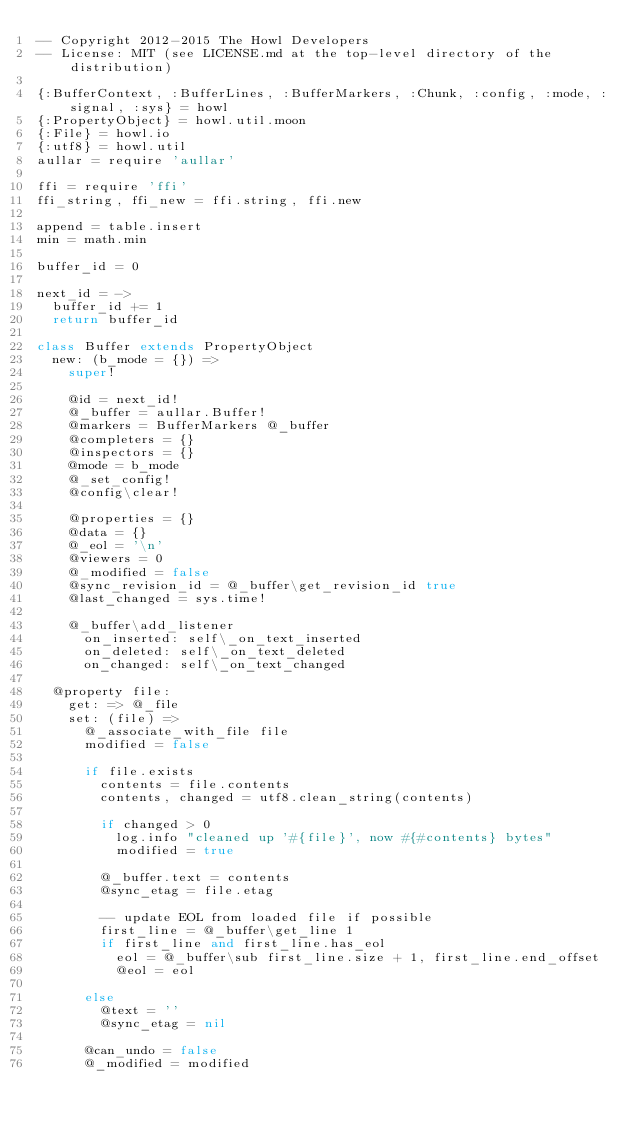<code> <loc_0><loc_0><loc_500><loc_500><_MoonScript_>-- Copyright 2012-2015 The Howl Developers
-- License: MIT (see LICENSE.md at the top-level directory of the distribution)

{:BufferContext, :BufferLines, :BufferMarkers, :Chunk, :config, :mode, :signal, :sys} = howl
{:PropertyObject} = howl.util.moon
{:File} = howl.io
{:utf8} = howl.util
aullar = require 'aullar'

ffi = require 'ffi'
ffi_string, ffi_new = ffi.string, ffi.new

append = table.insert
min = math.min

buffer_id = 0

next_id = ->
  buffer_id += 1
  return buffer_id

class Buffer extends PropertyObject
  new: (b_mode = {}) =>
    super!

    @id = next_id!
    @_buffer = aullar.Buffer!
    @markers = BufferMarkers @_buffer
    @completers = {}
    @inspectors = {}
    @mode = b_mode
    @_set_config!
    @config\clear!

    @properties = {}
    @data = {}
    @_eol = '\n'
    @viewers = 0
    @_modified = false
    @sync_revision_id = @_buffer\get_revision_id true
    @last_changed = sys.time!

    @_buffer\add_listener
      on_inserted: self\_on_text_inserted
      on_deleted: self\_on_text_deleted
      on_changed: self\_on_text_changed

  @property file:
    get: => @_file
    set: (file) =>
      @_associate_with_file file
      modified = false

      if file.exists
        contents = file.contents
        contents, changed = utf8.clean_string(contents)

        if changed > 0
          log.info "cleaned up '#{file}', now #{#contents} bytes"
          modified = true

        @_buffer.text = contents
        @sync_etag = file.etag

        -- update EOL from loaded file if possible
        first_line = @_buffer\get_line 1
        if first_line and first_line.has_eol
          eol = @_buffer\sub first_line.size + 1, first_line.end_offset
          @eol = eol

      else
        @text = ''
        @sync_etag = nil

      @can_undo = false
      @_modified = modified</code> 